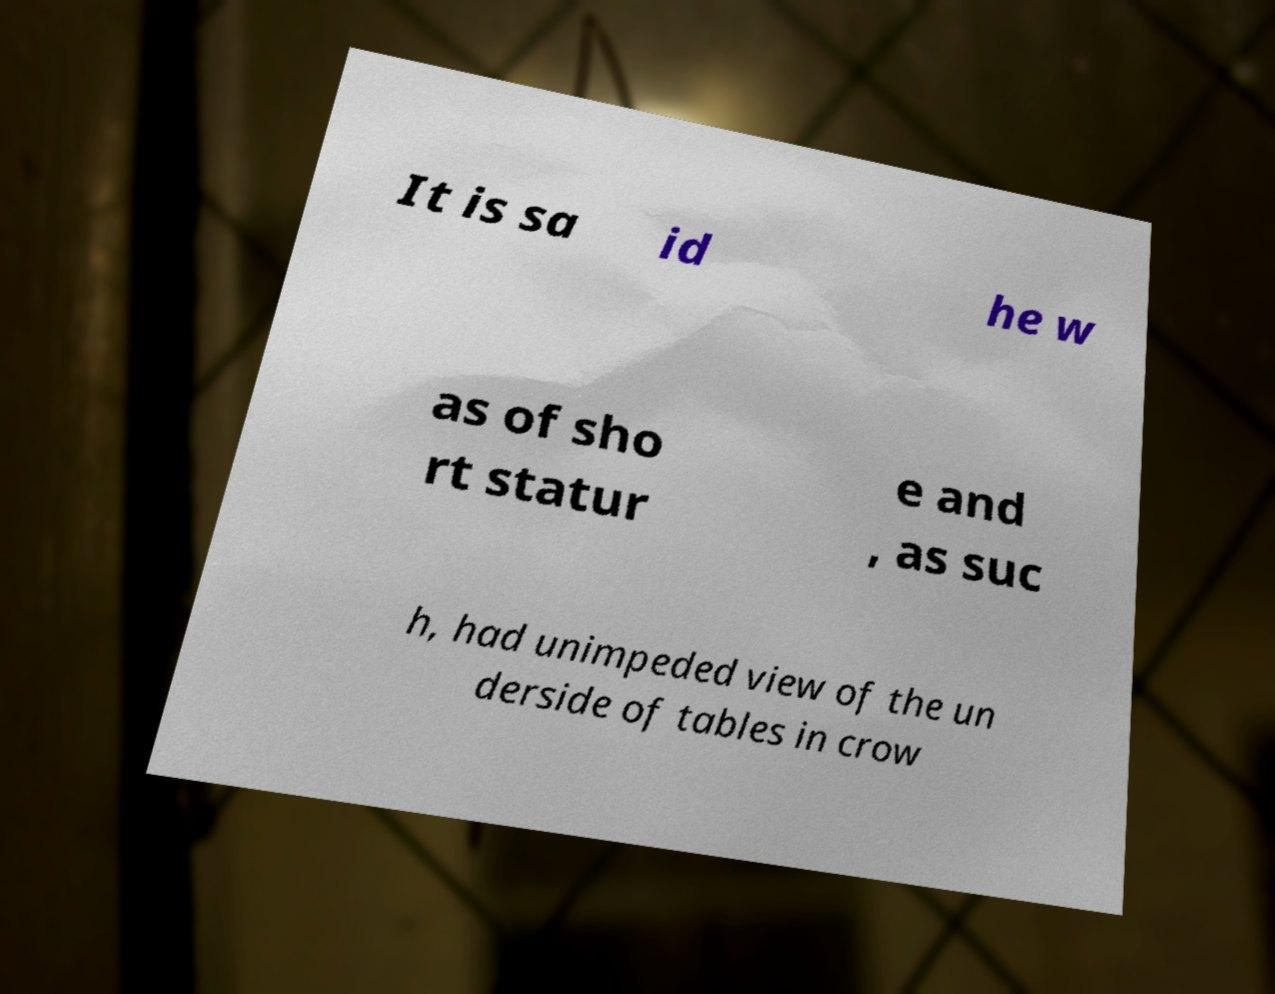I need the written content from this picture converted into text. Can you do that? It is sa id he w as of sho rt statur e and , as suc h, had unimpeded view of the un derside of tables in crow 